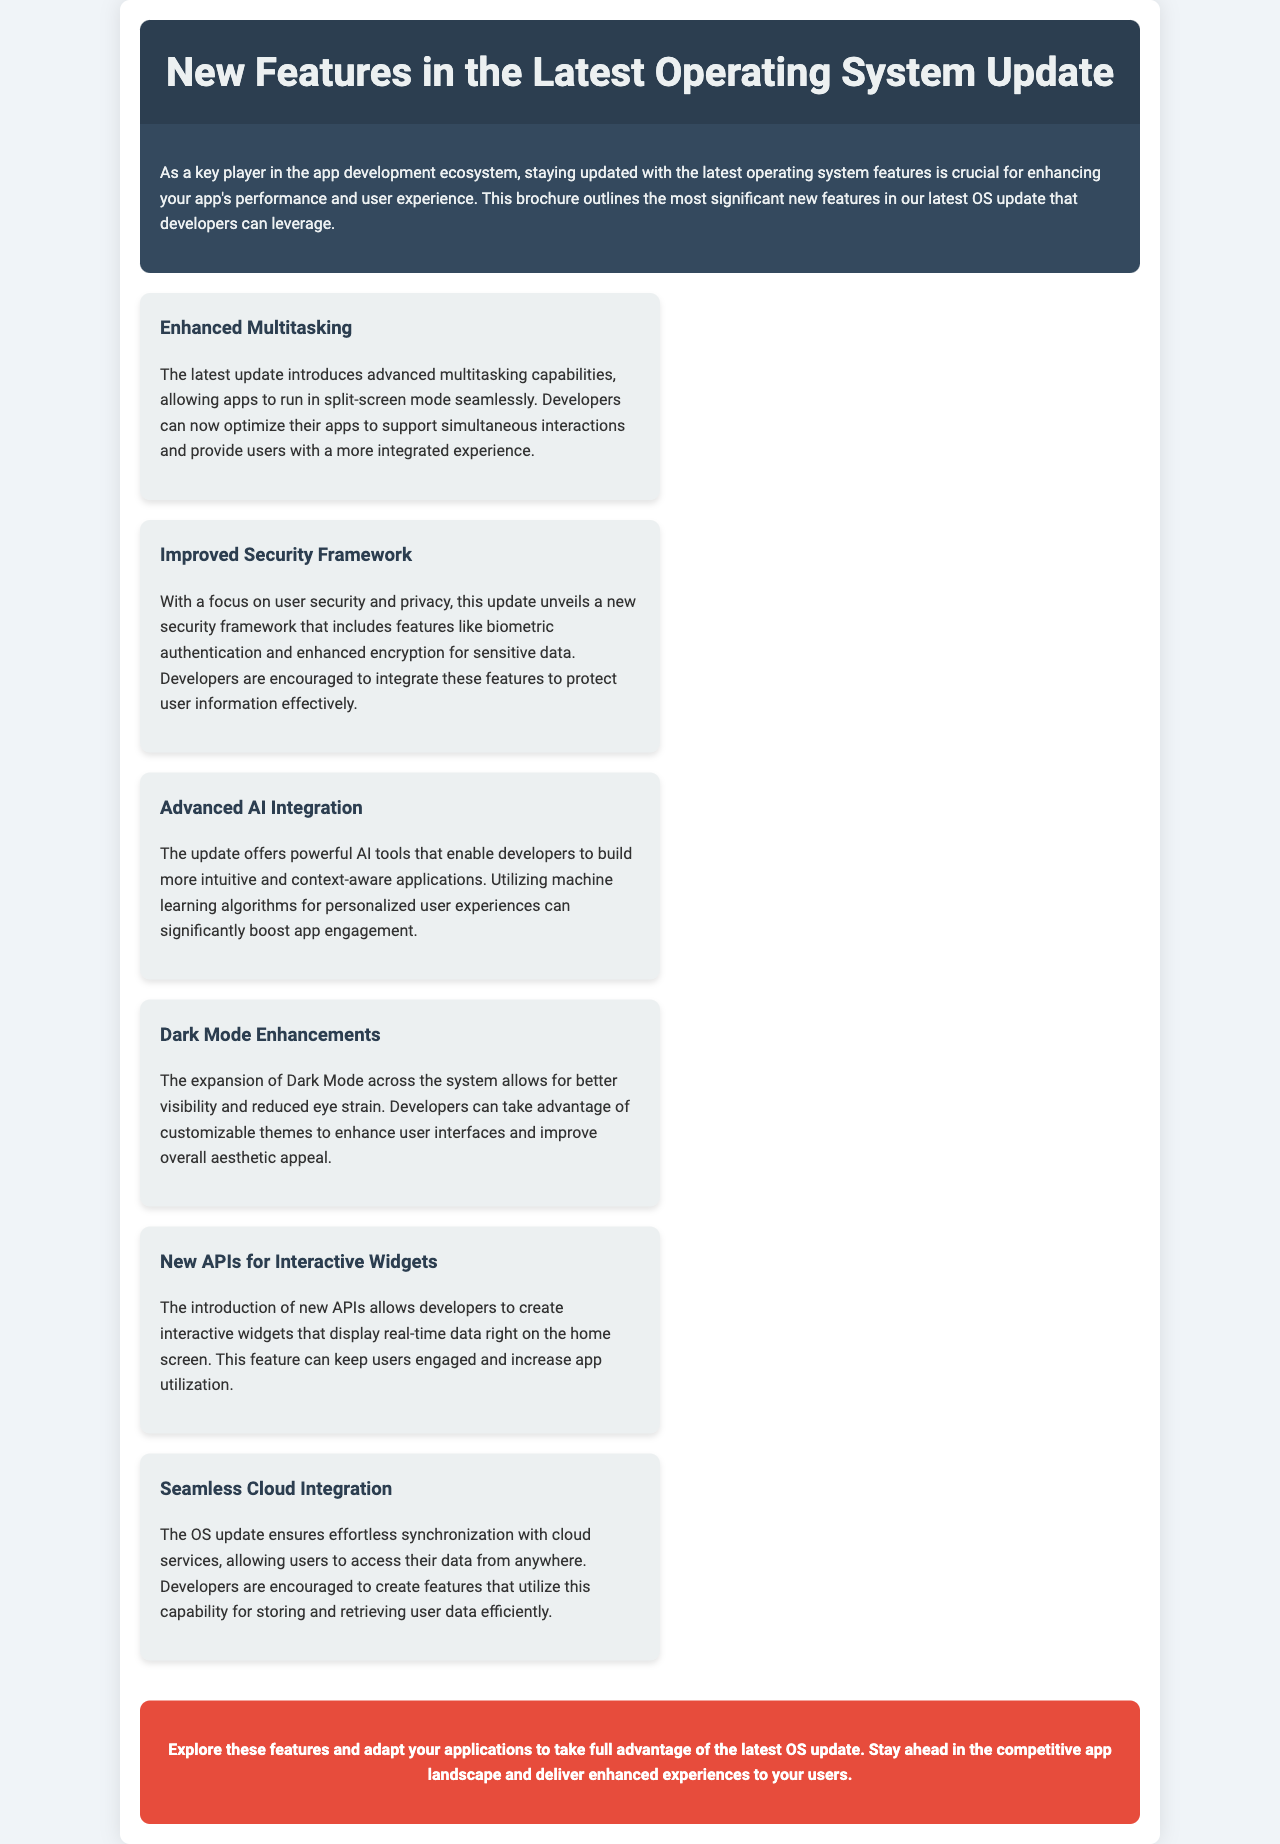What is the title of the brochure? The title is stated at the top of the document in the header section.
Answer: New Features in the Latest Operating System Update What is one of the key features aimed at enhancing user experience? The features are listed within the brochure, highlighting significant updates.
Answer: Enhanced Multitasking What does the new security framework focus on? The document mentions specific areas of focus for the security framework.
Answer: User security and privacy What can developers create with the new APIs introduced? The brochure describes capabilities that the new APIs provide for app developers.
Answer: Interactive widgets Which feature is related to user interface customization? The brochure discusses various aspects of Dark Mode in relation to app development.
Answer: Dark Mode Enhancements How many significant new features are mentioned? The document explicitly lists the features provided in the features section.
Answer: Six 